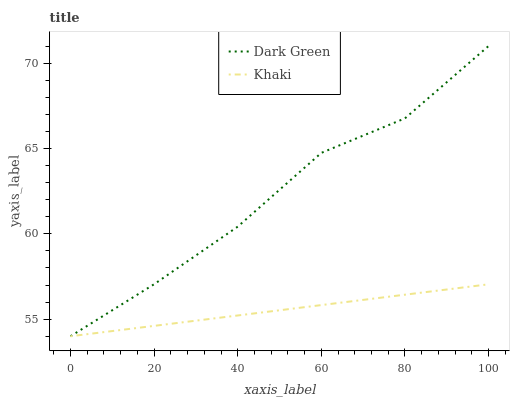Does Khaki have the minimum area under the curve?
Answer yes or no. Yes. Does Dark Green have the maximum area under the curve?
Answer yes or no. Yes. Does Dark Green have the minimum area under the curve?
Answer yes or no. No. Is Khaki the smoothest?
Answer yes or no. Yes. Is Dark Green the roughest?
Answer yes or no. Yes. Is Dark Green the smoothest?
Answer yes or no. No. Does Khaki have the lowest value?
Answer yes or no. Yes. Does Dark Green have the highest value?
Answer yes or no. Yes. Does Dark Green intersect Khaki?
Answer yes or no. Yes. Is Dark Green less than Khaki?
Answer yes or no. No. Is Dark Green greater than Khaki?
Answer yes or no. No. 